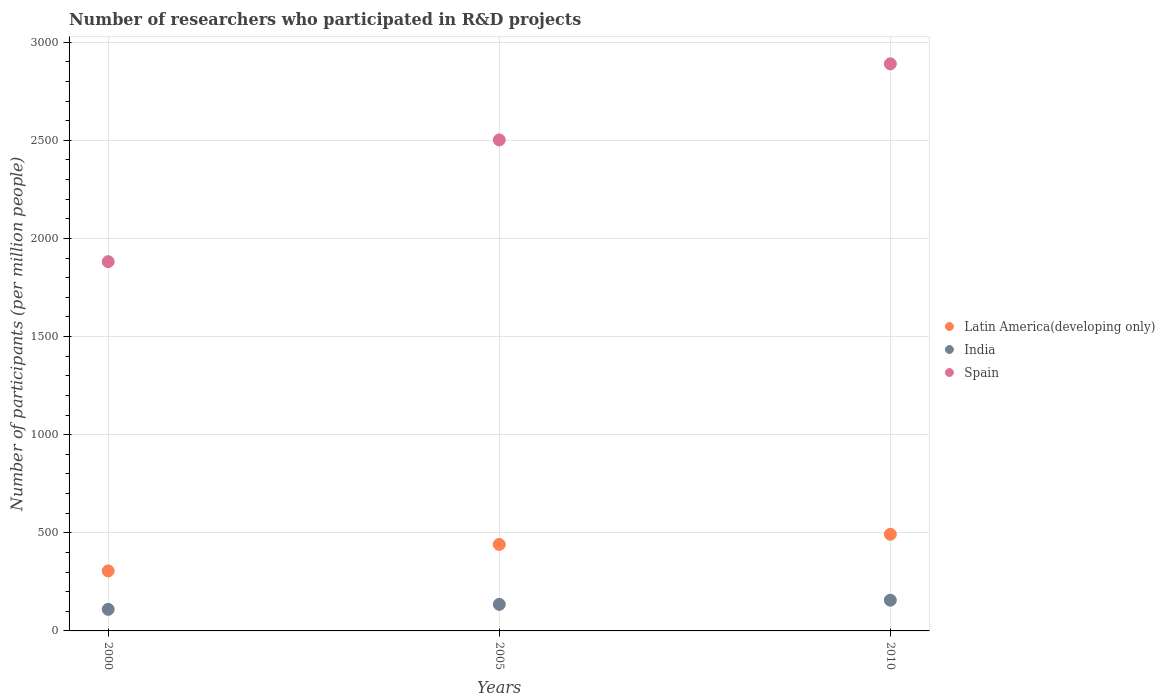How many different coloured dotlines are there?
Offer a terse response. 3. What is the number of researchers who participated in R&D projects in Spain in 2005?
Your answer should be compact. 2501.9. Across all years, what is the maximum number of researchers who participated in R&D projects in India?
Your answer should be compact. 156.64. Across all years, what is the minimum number of researchers who participated in R&D projects in Spain?
Keep it short and to the point. 1881.47. In which year was the number of researchers who participated in R&D projects in Latin America(developing only) minimum?
Keep it short and to the point. 2000. What is the total number of researchers who participated in R&D projects in India in the graph?
Your answer should be compact. 401.99. What is the difference between the number of researchers who participated in R&D projects in India in 2005 and that in 2010?
Your answer should be very brief. -21.34. What is the difference between the number of researchers who participated in R&D projects in India in 2000 and the number of researchers who participated in R&D projects in Latin America(developing only) in 2010?
Offer a terse response. -382.31. What is the average number of researchers who participated in R&D projects in India per year?
Provide a succinct answer. 134. In the year 2010, what is the difference between the number of researchers who participated in R&D projects in Spain and number of researchers who participated in R&D projects in Latin America(developing only)?
Your response must be concise. 2397.09. In how many years, is the number of researchers who participated in R&D projects in India greater than 1200?
Give a very brief answer. 0. What is the ratio of the number of researchers who participated in R&D projects in India in 2000 to that in 2010?
Give a very brief answer. 0.7. What is the difference between the highest and the second highest number of researchers who participated in R&D projects in Latin America(developing only)?
Your answer should be compact. 51.75. What is the difference between the highest and the lowest number of researchers who participated in R&D projects in India?
Provide a short and direct response. 46.59. Is it the case that in every year, the sum of the number of researchers who participated in R&D projects in Spain and number of researchers who participated in R&D projects in Latin America(developing only)  is greater than the number of researchers who participated in R&D projects in India?
Ensure brevity in your answer.  Yes. Is the number of researchers who participated in R&D projects in Latin America(developing only) strictly greater than the number of researchers who participated in R&D projects in India over the years?
Offer a very short reply. Yes. Is the number of researchers who participated in R&D projects in Spain strictly less than the number of researchers who participated in R&D projects in Latin America(developing only) over the years?
Your answer should be compact. No. How many dotlines are there?
Give a very brief answer. 3. How many years are there in the graph?
Give a very brief answer. 3. Does the graph contain any zero values?
Your answer should be compact. No. Does the graph contain grids?
Your answer should be very brief. Yes. Where does the legend appear in the graph?
Offer a terse response. Center right. How many legend labels are there?
Ensure brevity in your answer.  3. How are the legend labels stacked?
Offer a terse response. Vertical. What is the title of the graph?
Provide a succinct answer. Number of researchers who participated in R&D projects. What is the label or title of the Y-axis?
Your response must be concise. Number of participants (per million people). What is the Number of participants (per million people) of Latin America(developing only) in 2000?
Your response must be concise. 305.72. What is the Number of participants (per million people) in India in 2000?
Keep it short and to the point. 110.05. What is the Number of participants (per million people) in Spain in 2000?
Offer a very short reply. 1881.47. What is the Number of participants (per million people) in Latin America(developing only) in 2005?
Your answer should be very brief. 440.62. What is the Number of participants (per million people) in India in 2005?
Provide a succinct answer. 135.3. What is the Number of participants (per million people) in Spain in 2005?
Keep it short and to the point. 2501.9. What is the Number of participants (per million people) of Latin America(developing only) in 2010?
Your answer should be compact. 492.36. What is the Number of participants (per million people) of India in 2010?
Offer a terse response. 156.64. What is the Number of participants (per million people) of Spain in 2010?
Provide a short and direct response. 2889.46. Across all years, what is the maximum Number of participants (per million people) in Latin America(developing only)?
Keep it short and to the point. 492.36. Across all years, what is the maximum Number of participants (per million people) of India?
Offer a very short reply. 156.64. Across all years, what is the maximum Number of participants (per million people) in Spain?
Offer a terse response. 2889.46. Across all years, what is the minimum Number of participants (per million people) of Latin America(developing only)?
Ensure brevity in your answer.  305.72. Across all years, what is the minimum Number of participants (per million people) in India?
Your response must be concise. 110.05. Across all years, what is the minimum Number of participants (per million people) of Spain?
Offer a very short reply. 1881.47. What is the total Number of participants (per million people) of Latin America(developing only) in the graph?
Your answer should be very brief. 1238.7. What is the total Number of participants (per million people) in India in the graph?
Offer a very short reply. 401.99. What is the total Number of participants (per million people) of Spain in the graph?
Keep it short and to the point. 7272.83. What is the difference between the Number of participants (per million people) in Latin America(developing only) in 2000 and that in 2005?
Provide a short and direct response. -134.9. What is the difference between the Number of participants (per million people) in India in 2000 and that in 2005?
Make the answer very short. -25.25. What is the difference between the Number of participants (per million people) of Spain in 2000 and that in 2005?
Offer a very short reply. -620.43. What is the difference between the Number of participants (per million people) of Latin America(developing only) in 2000 and that in 2010?
Offer a very short reply. -186.64. What is the difference between the Number of participants (per million people) in India in 2000 and that in 2010?
Ensure brevity in your answer.  -46.59. What is the difference between the Number of participants (per million people) in Spain in 2000 and that in 2010?
Make the answer very short. -1007.98. What is the difference between the Number of participants (per million people) in Latin America(developing only) in 2005 and that in 2010?
Provide a short and direct response. -51.75. What is the difference between the Number of participants (per million people) of India in 2005 and that in 2010?
Keep it short and to the point. -21.34. What is the difference between the Number of participants (per million people) of Spain in 2005 and that in 2010?
Your response must be concise. -387.56. What is the difference between the Number of participants (per million people) of Latin America(developing only) in 2000 and the Number of participants (per million people) of India in 2005?
Your response must be concise. 170.42. What is the difference between the Number of participants (per million people) of Latin America(developing only) in 2000 and the Number of participants (per million people) of Spain in 2005?
Offer a terse response. -2196.18. What is the difference between the Number of participants (per million people) in India in 2000 and the Number of participants (per million people) in Spain in 2005?
Offer a terse response. -2391.85. What is the difference between the Number of participants (per million people) of Latin America(developing only) in 2000 and the Number of participants (per million people) of India in 2010?
Your answer should be very brief. 149.08. What is the difference between the Number of participants (per million people) of Latin America(developing only) in 2000 and the Number of participants (per million people) of Spain in 2010?
Offer a very short reply. -2583.74. What is the difference between the Number of participants (per million people) in India in 2000 and the Number of participants (per million people) in Spain in 2010?
Keep it short and to the point. -2779.41. What is the difference between the Number of participants (per million people) in Latin America(developing only) in 2005 and the Number of participants (per million people) in India in 2010?
Offer a very short reply. 283.98. What is the difference between the Number of participants (per million people) of Latin America(developing only) in 2005 and the Number of participants (per million people) of Spain in 2010?
Your answer should be compact. -2448.84. What is the difference between the Number of participants (per million people) of India in 2005 and the Number of participants (per million people) of Spain in 2010?
Offer a terse response. -2754.16. What is the average Number of participants (per million people) of Latin America(developing only) per year?
Your answer should be very brief. 412.9. What is the average Number of participants (per million people) in India per year?
Keep it short and to the point. 134. What is the average Number of participants (per million people) of Spain per year?
Offer a very short reply. 2424.28. In the year 2000, what is the difference between the Number of participants (per million people) of Latin America(developing only) and Number of participants (per million people) of India?
Provide a short and direct response. 195.67. In the year 2000, what is the difference between the Number of participants (per million people) in Latin America(developing only) and Number of participants (per million people) in Spain?
Give a very brief answer. -1575.75. In the year 2000, what is the difference between the Number of participants (per million people) in India and Number of participants (per million people) in Spain?
Keep it short and to the point. -1771.42. In the year 2005, what is the difference between the Number of participants (per million people) of Latin America(developing only) and Number of participants (per million people) of India?
Provide a succinct answer. 305.32. In the year 2005, what is the difference between the Number of participants (per million people) of Latin America(developing only) and Number of participants (per million people) of Spain?
Offer a terse response. -2061.29. In the year 2005, what is the difference between the Number of participants (per million people) in India and Number of participants (per million people) in Spain?
Make the answer very short. -2366.6. In the year 2010, what is the difference between the Number of participants (per million people) in Latin America(developing only) and Number of participants (per million people) in India?
Make the answer very short. 335.73. In the year 2010, what is the difference between the Number of participants (per million people) of Latin America(developing only) and Number of participants (per million people) of Spain?
Ensure brevity in your answer.  -2397.09. In the year 2010, what is the difference between the Number of participants (per million people) in India and Number of participants (per million people) in Spain?
Offer a terse response. -2732.82. What is the ratio of the Number of participants (per million people) in Latin America(developing only) in 2000 to that in 2005?
Offer a very short reply. 0.69. What is the ratio of the Number of participants (per million people) of India in 2000 to that in 2005?
Your answer should be compact. 0.81. What is the ratio of the Number of participants (per million people) in Spain in 2000 to that in 2005?
Offer a terse response. 0.75. What is the ratio of the Number of participants (per million people) of Latin America(developing only) in 2000 to that in 2010?
Provide a short and direct response. 0.62. What is the ratio of the Number of participants (per million people) in India in 2000 to that in 2010?
Keep it short and to the point. 0.7. What is the ratio of the Number of participants (per million people) of Spain in 2000 to that in 2010?
Offer a terse response. 0.65. What is the ratio of the Number of participants (per million people) in Latin America(developing only) in 2005 to that in 2010?
Provide a succinct answer. 0.89. What is the ratio of the Number of participants (per million people) in India in 2005 to that in 2010?
Your answer should be compact. 0.86. What is the ratio of the Number of participants (per million people) of Spain in 2005 to that in 2010?
Offer a terse response. 0.87. What is the difference between the highest and the second highest Number of participants (per million people) in Latin America(developing only)?
Offer a very short reply. 51.75. What is the difference between the highest and the second highest Number of participants (per million people) in India?
Provide a short and direct response. 21.34. What is the difference between the highest and the second highest Number of participants (per million people) in Spain?
Provide a succinct answer. 387.56. What is the difference between the highest and the lowest Number of participants (per million people) in Latin America(developing only)?
Offer a very short reply. 186.64. What is the difference between the highest and the lowest Number of participants (per million people) in India?
Offer a very short reply. 46.59. What is the difference between the highest and the lowest Number of participants (per million people) in Spain?
Your answer should be very brief. 1007.98. 